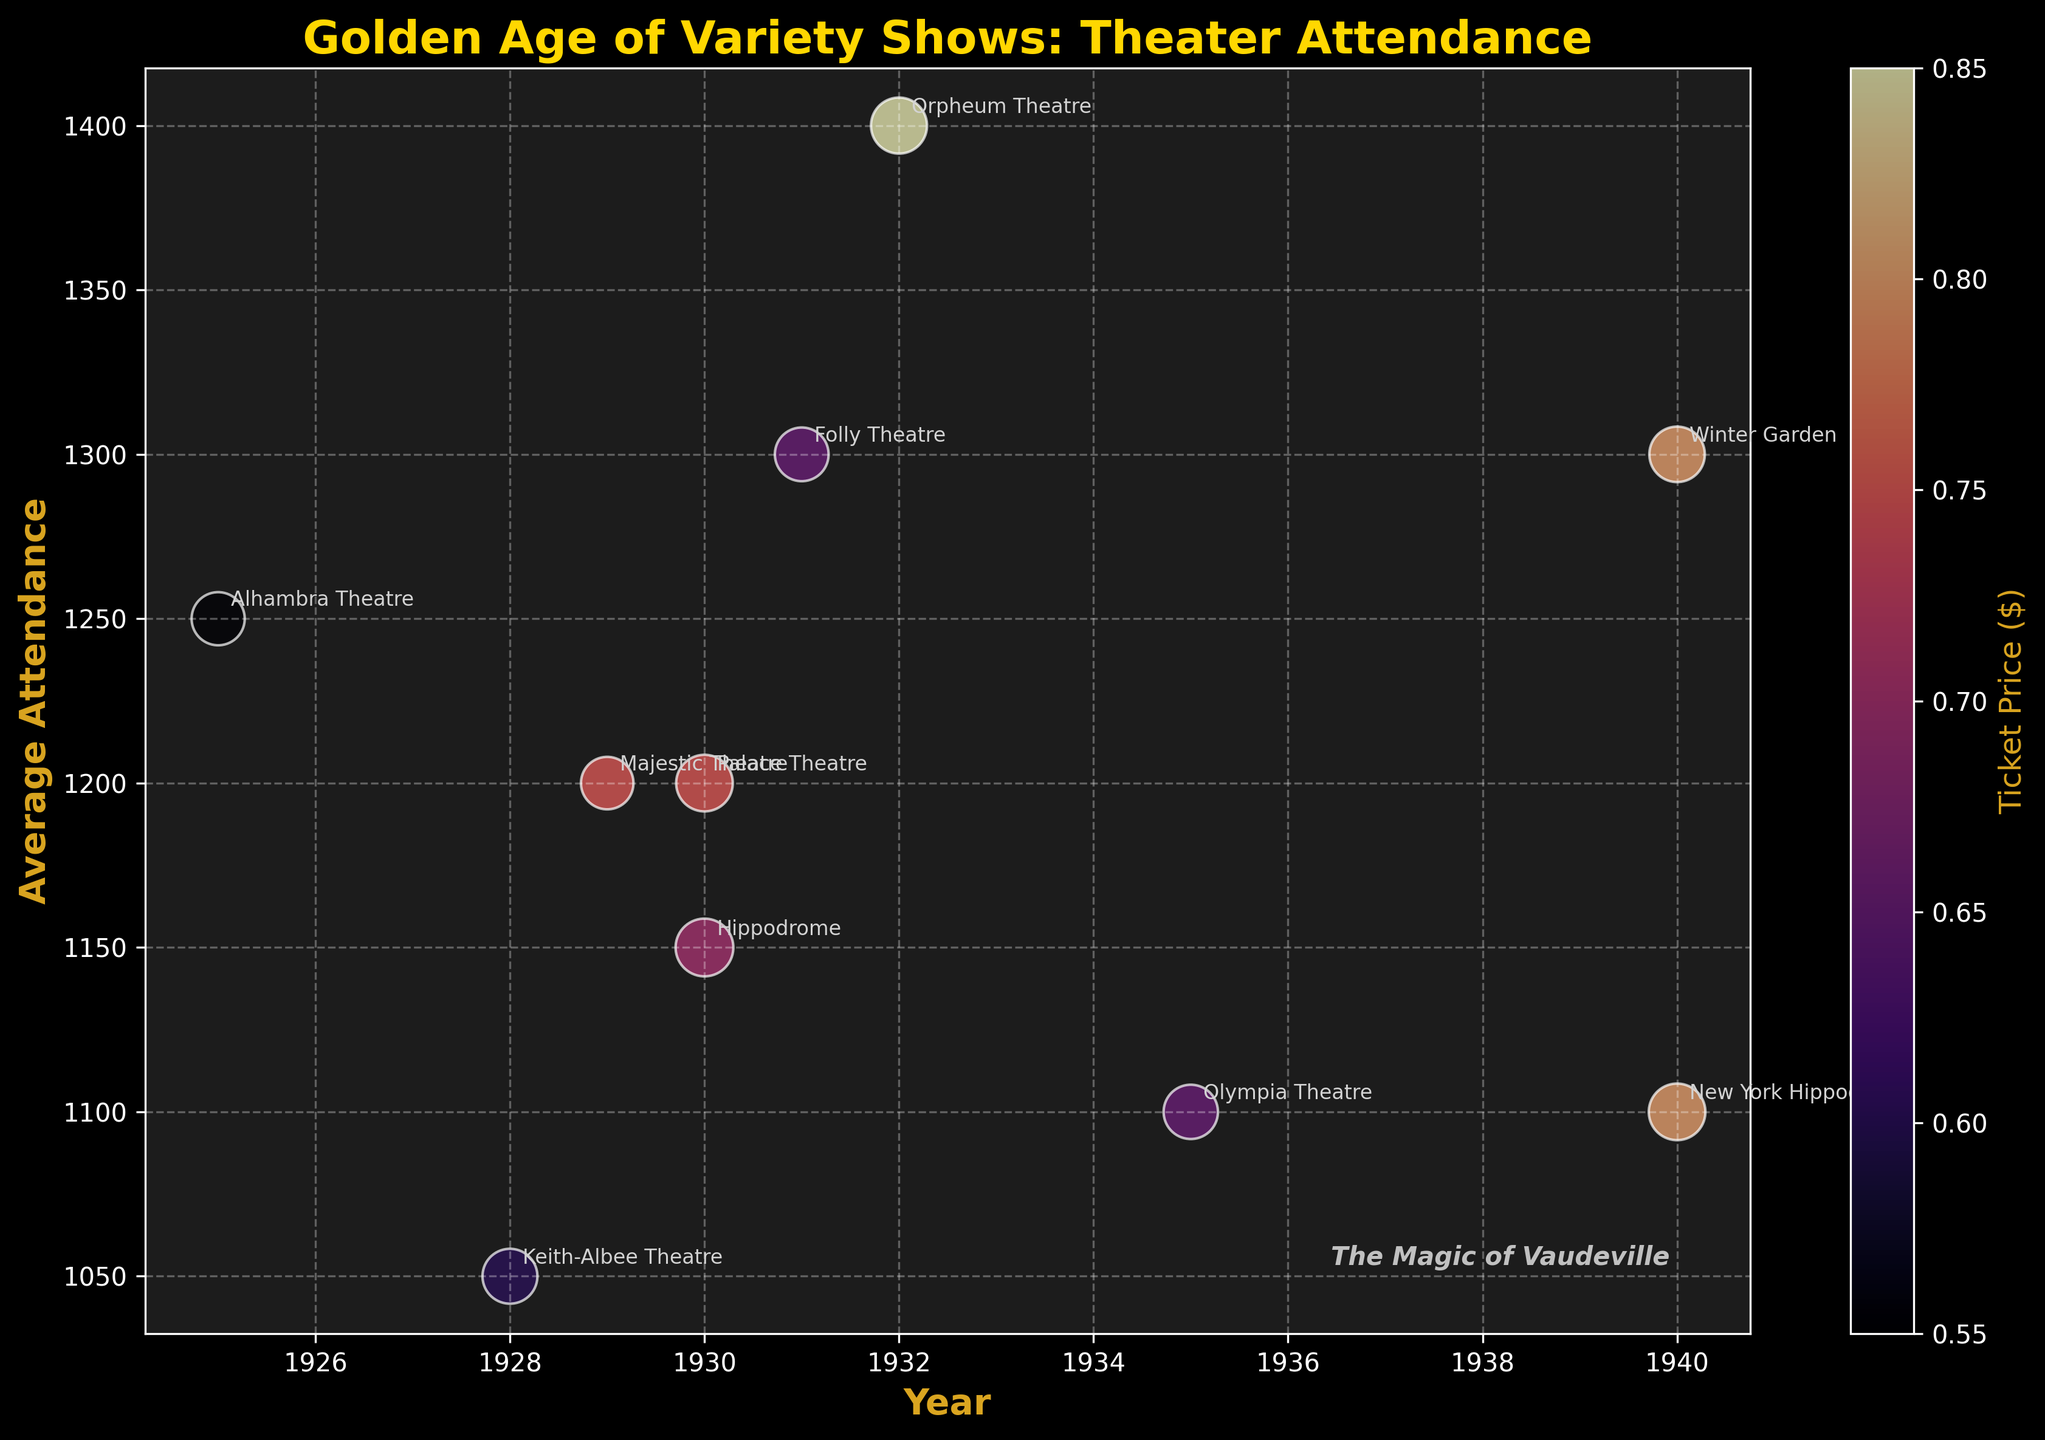what is the title of the figure? The title of the figure is displayed prominently at the top. It states the main topic of the visualization, which in this case is related to theater attendance during the Golden Age of Variety Shows.
Answer: Golden Age of Variety Shows: Theater Attendance How many theaters are represented in the figure? Each theater is represented by a distinct bubble on the chart. By counting the number of bubbles, we can determine the number of theaters. Annotated labels for each theater facilitate this process.
Answer: 10 What is the range of years displayed on the x-axis? The x-axis represents the years. By looking at the minimum and maximum values along this axis, we get the range.
Answer: 1925-1940 Which theater had the highest average attendance? To find the theater with the highest number of attendees, locate the bubble that is highest on the y-axis. By referring to the annotated labels, we can identify this theater.
Answer: Orpheum Theatre Which bubble represents the theater with the lowest ticket price? The color of each bubble corresponds to ticket prices. The color bar on the right helps determine this. By finding the bubble with the darkest shade (indicating the lowest price on the scale), we can identify the theater.
Answer: Alhambra Theatre Which theater had more shows, Palace Theatre in 1930 or Hippodrome in 1930? Compare the sizes of the two bubbles for these theaters. The size of the bubbles represents the number of shows, with larger bubbles indicating more shows.
Answer: Hippodrome What is the combined average attendance of theaters represented in the year 1940? Identify the bubbles from the year 1940, then sum their respective average attendances by referring to their y-axis positions.
Answer: 2400 Which theater had a higher ticket price in 1930, Palace Theatre or Hippodrome? Compare the colors of the two bubbles for these theaters using the color bar to determine which theater had a higher ticket price.
Answer: Palace Theatre What’s the difference in show count between Majestic Theatre and Keith-Albee Theatre? By comparing the sizes of the corresponding bubbles, we can calculate the difference.
Answer: 20 Which two theaters had the same average attendance of 1300? By identifying bubbles at the 1300 mark on the y-axis and referring to their annotated labels, we can determine which theaters share this average attendance.
Answer: Winter Garden and Folly Theatre 